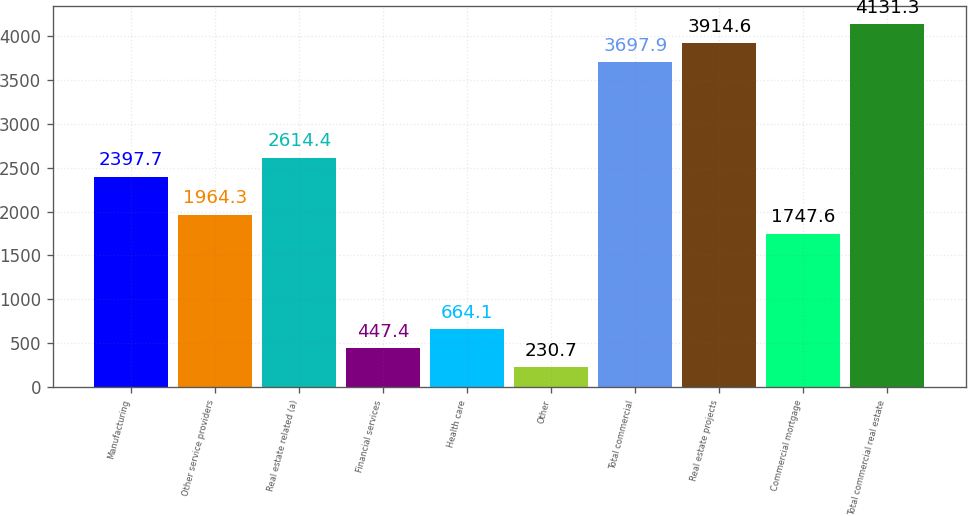<chart> <loc_0><loc_0><loc_500><loc_500><bar_chart><fcel>Manufacturing<fcel>Other service providers<fcel>Real estate related (a)<fcel>Financial services<fcel>Health care<fcel>Other<fcel>Total commercial<fcel>Real estate projects<fcel>Commercial mortgage<fcel>Total commercial real estate<nl><fcel>2397.7<fcel>1964.3<fcel>2614.4<fcel>447.4<fcel>664.1<fcel>230.7<fcel>3697.9<fcel>3914.6<fcel>1747.6<fcel>4131.3<nl></chart> 